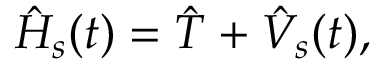Convert formula to latex. <formula><loc_0><loc_0><loc_500><loc_500>{ \hat { H } } _ { s } ( t ) = { \hat { T } } + { \hat { V } } _ { s } ( t ) ,</formula> 